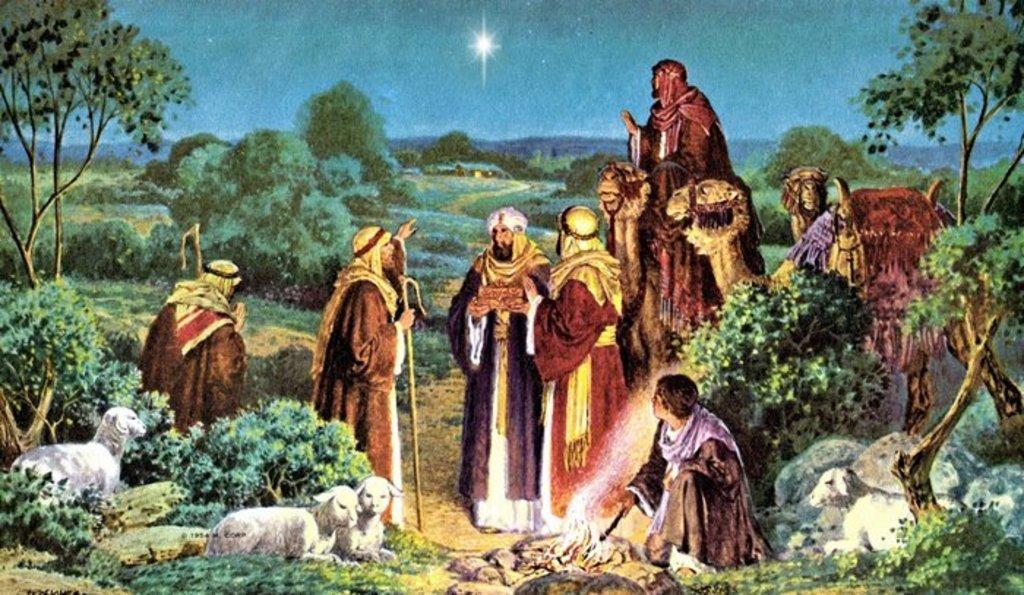Can you describe this image briefly? This image is a painting. In this image we can see people and there are animals. In the background there are trees, hills and sky. 